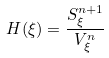Convert formula to latex. <formula><loc_0><loc_0><loc_500><loc_500>H ( \xi ) = \frac { S ^ { n + 1 } _ { \xi } } { V _ { \xi } ^ { n } }</formula> 